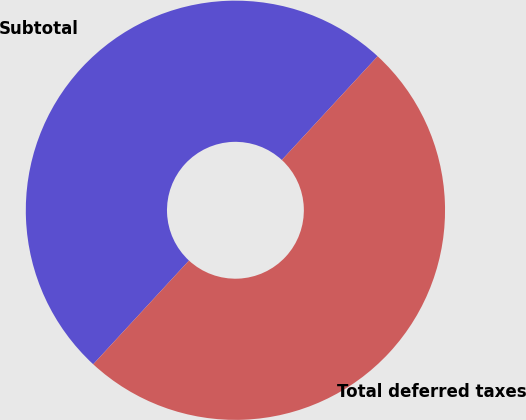Convert chart to OTSL. <chart><loc_0><loc_0><loc_500><loc_500><pie_chart><fcel>Subtotal<fcel>Total deferred taxes<nl><fcel>50.0%<fcel>50.0%<nl></chart> 